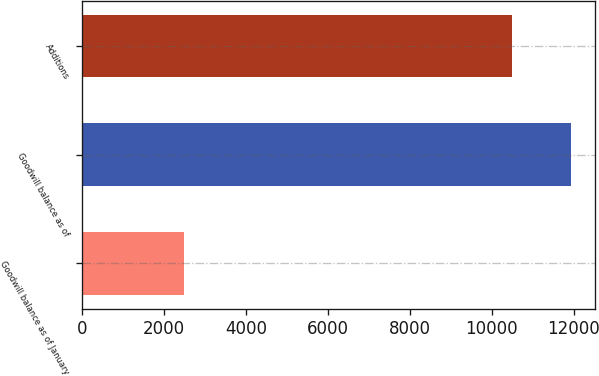<chart> <loc_0><loc_0><loc_500><loc_500><bar_chart><fcel>Goodwill balance as of January<fcel>Goodwill balance as of<fcel>Additions<nl><fcel>2487.14<fcel>11923.1<fcel>10484.4<nl></chart> 